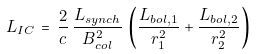Convert formula to latex. <formula><loc_0><loc_0><loc_500><loc_500>L _ { I C } \, = \, \frac { 2 } { c } \, \frac { L _ { s y n c h } } { B _ { c o l } ^ { 2 } } \, \left ( \frac { L _ { b o l , 1 } } { r _ { 1 } ^ { 2 } } + \frac { L _ { b o l , 2 } } { r _ { 2 } ^ { 2 } } \right )</formula> 